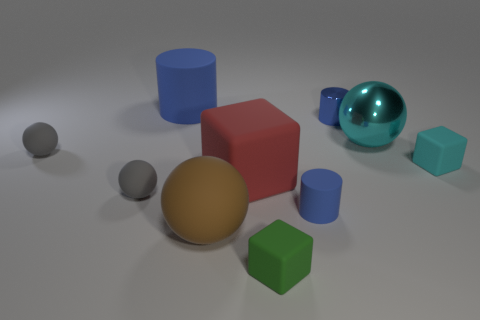There is a big thing that is the same color as the small metallic thing; what shape is it?
Offer a terse response. Cylinder. Is the color of the large cylinder left of the large red block the same as the tiny metallic thing?
Ensure brevity in your answer.  Yes. Is there any other thing of the same color as the tiny metallic cylinder?
Offer a very short reply. Yes. Are there more blue cylinders on the right side of the brown object than metal cylinders?
Offer a terse response. Yes. Does the green thing have the same size as the red rubber thing?
Keep it short and to the point. No. There is a cyan thing that is the same shape as the brown thing; what material is it?
Keep it short and to the point. Metal. How many blue things are tiny cubes or tiny metallic objects?
Your response must be concise. 1. There is a sphere to the right of the blue metal cylinder; what is it made of?
Your answer should be very brief. Metal. Are there more green matte objects than small gray rubber cubes?
Make the answer very short. Yes. Does the big rubber object left of the large brown ball have the same shape as the blue metallic thing?
Your answer should be very brief. Yes. 